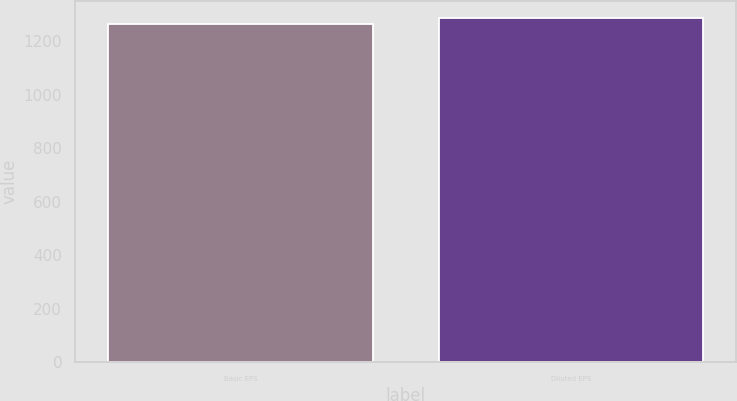Convert chart to OTSL. <chart><loc_0><loc_0><loc_500><loc_500><bar_chart><fcel>Basic EPS<fcel>Diluted EPS<nl><fcel>1266.4<fcel>1287.9<nl></chart> 